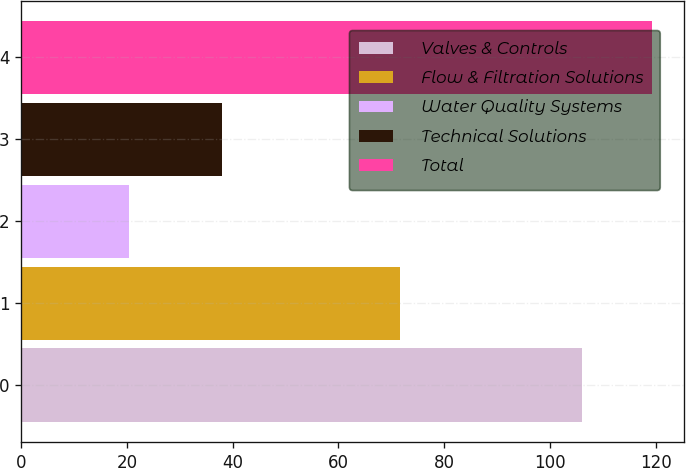Convert chart. <chart><loc_0><loc_0><loc_500><loc_500><bar_chart><fcel>Valves & Controls<fcel>Flow & Filtration Solutions<fcel>Water Quality Systems<fcel>Technical Solutions<fcel>Total<nl><fcel>106.1<fcel>71.6<fcel>20.4<fcel>38<fcel>119.3<nl></chart> 